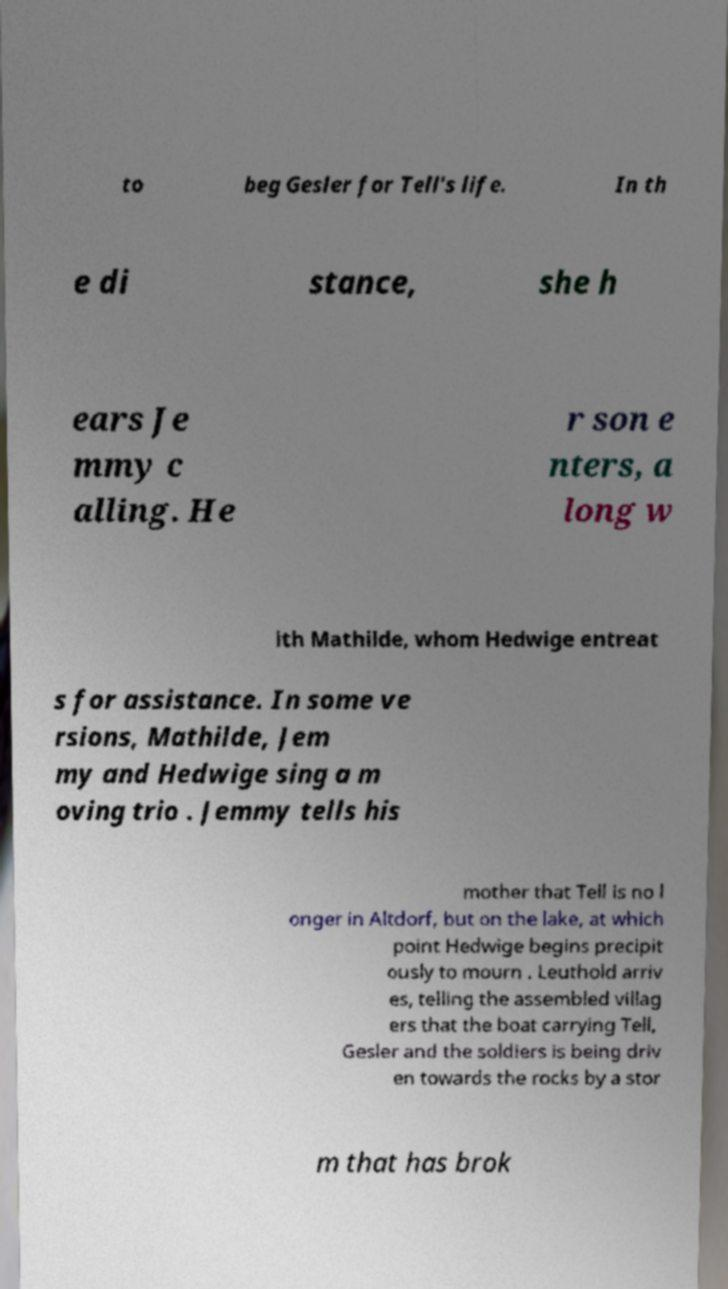For documentation purposes, I need the text within this image transcribed. Could you provide that? to beg Gesler for Tell's life. In th e di stance, she h ears Je mmy c alling. He r son e nters, a long w ith Mathilde, whom Hedwige entreat s for assistance. In some ve rsions, Mathilde, Jem my and Hedwige sing a m oving trio . Jemmy tells his mother that Tell is no l onger in Altdorf, but on the lake, at which point Hedwige begins precipit ously to mourn . Leuthold arriv es, telling the assembled villag ers that the boat carrying Tell, Gesler and the soldiers is being driv en towards the rocks by a stor m that has brok 